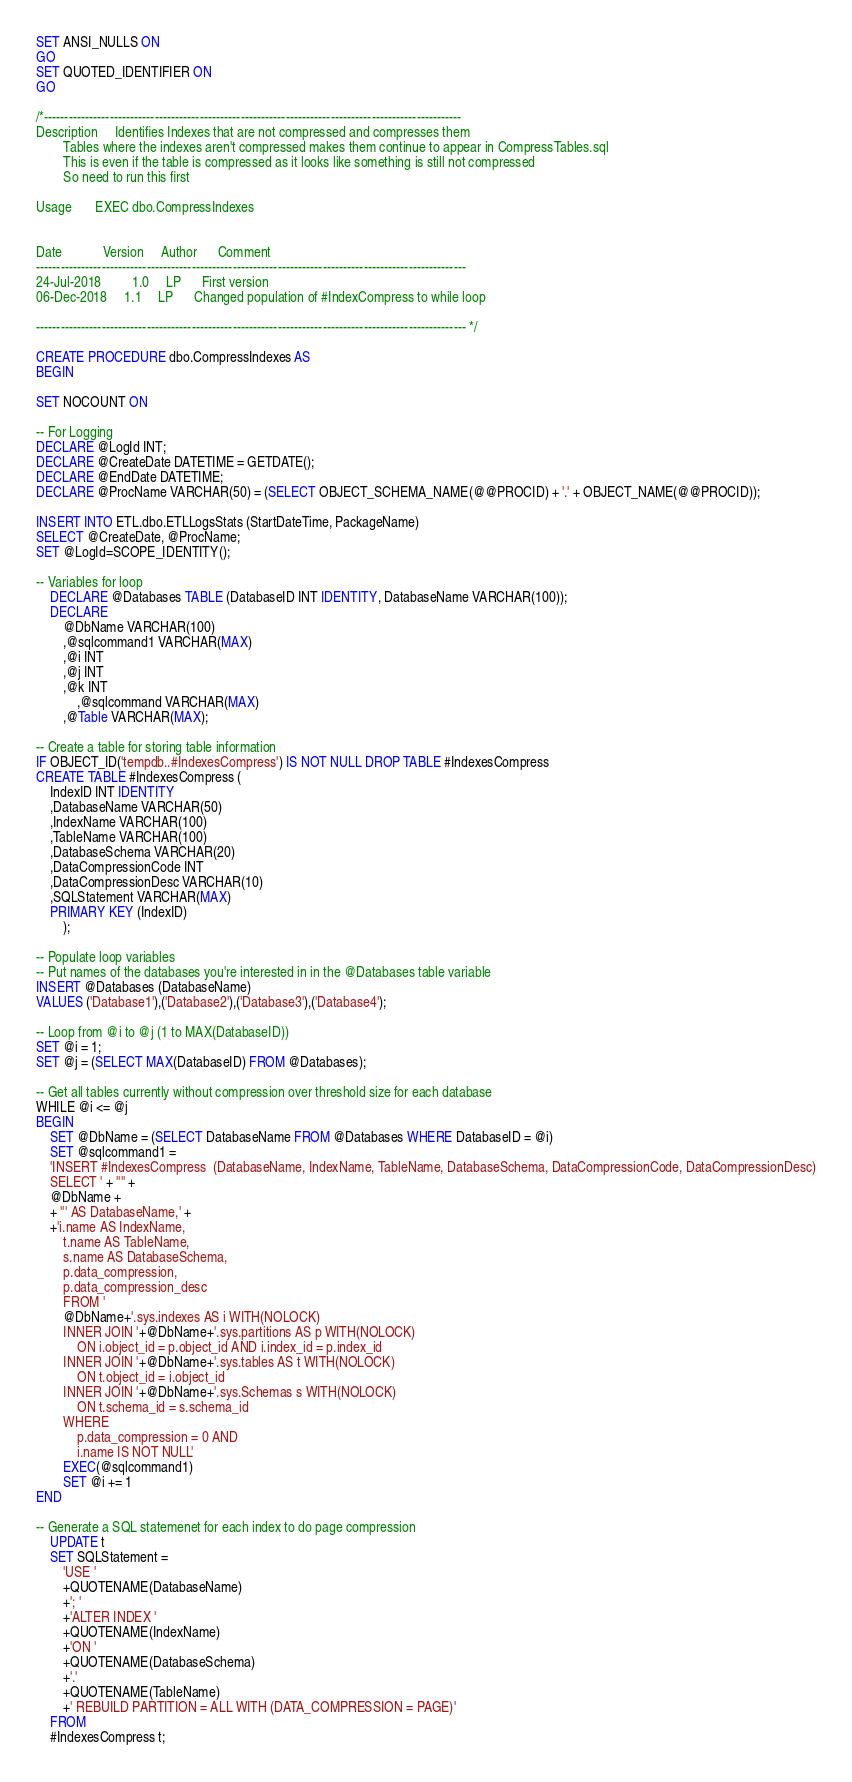Convert code to text. <code><loc_0><loc_0><loc_500><loc_500><_SQL_>SET ANSI_NULLS ON
GO
SET QUOTED_IDENTIFIER ON
GO

/*------------------------------------------------------------------------------------------------------ 
Description   	Identifies Indexes that are not compressed and compresses them
		Tables where the indexes aren't compressed makes them continue to appear in CompressTables.sql
		This is even if the table is compressed as it looks like something is still not compressed
		So need to run this first

Usage		EXEC dbo.CompressIndexes

                 
Date			Version		Author		Comment
---------------------------------------------------------------------------------------------------------
24-Jul-2018	     	1.0		LP		First version
06-Dec-2018		1.1		LP		Changed population of #IndexCompress to while loop

--------------------------------------------------------------------------------------------------------- */

CREATE PROCEDURE dbo.CompressIndexes AS 
BEGIN 

SET NOCOUNT ON

-- For Logging
DECLARE @LogId INT;
DECLARE @CreateDate DATETIME = GETDATE();
DECLARE @EndDate DATETIME;
DECLARE @ProcName VARCHAR(50) = (SELECT OBJECT_SCHEMA_NAME(@@PROCID) + '.' + OBJECT_NAME(@@PROCID));

INSERT INTO ETL.dbo.ETLLogsStats (StartDateTime, PackageName)
SELECT @CreateDate, @ProcName;
SET @LogId=SCOPE_IDENTITY();

-- Variables for loop
	DECLARE @Databases TABLE (DatabaseID INT IDENTITY, DatabaseName VARCHAR(100));
	DECLARE 
		@DbName VARCHAR(100)
		,@sqlcommand1 VARCHAR(MAX)
		,@i INT
		,@j INT
		,@k INT
      		,@sqlcommand VARCHAR(MAX)
		,@Table VARCHAR(MAX);

-- Create a table for storing table information
IF OBJECT_ID('tempdb..#IndexesCompress') IS NOT NULL DROP TABLE #IndexesCompress
CREATE TABLE #IndexesCompress (
	IndexID INT IDENTITY
	,DatabaseName VARCHAR(50)
	,IndexName VARCHAR(100)
	,TableName VARCHAR(100)
	,DatabaseSchema VARCHAR(20)
	,DataCompressionCode INT
	,DataCompressionDesc VARCHAR(10)
	,SQLStatement VARCHAR(MAX)
	PRIMARY KEY (IndexID)
		);

-- Populate loop variables 
-- Put names of the databases you're interested in in the @Databases table variable
INSERT @Databases (DatabaseName) 
VALUES ('Database1'),('Database2'),('Database3'),('Database4');

-- Loop from @i to @j (1 to MAX(DatabaseID))
SET @i = 1;
SET @j = (SELECT MAX(DatabaseID) FROM @Databases);

-- Get all tables currently without compression over threshold size for each database
WHILE @i <= @j
BEGIN
	SET @DbName = (SELECT DatabaseName FROM @Databases WHERE DatabaseID = @i)
	SET @sqlcommand1 =
	'INSERT #IndexesCompress  (DatabaseName, IndexName, TableName, DatabaseSchema, DataCompressionCode, DataCompressionDesc)
	SELECT ' + '''' +
	@DbName +
	+ ''' AS DatabaseName,' +
	+'i.name AS IndexName,
		t.name AS TableName, 
		s.name AS DatabaseSchema,
		p.data_compression, 
		p.data_compression_desc
		FROM '
		@DbName+'.sys.indexes AS i WITH(NOLOCK)
		INNER JOIN '+@DbName+'.sys.partitions AS p WITH(NOLOCK) 
			ON i.object_id = p.object_id AND i.index_id = p.index_id
		INNER JOIN '+@DbName+'.sys.tables AS t WITH(NOLOCK) 
			ON t.object_id = i.object_id
		INNER JOIN '+@DbName+'.sys.Schemas s WITH(NOLOCK) 
			ON t.schema_id = s.schema_id
		WHERE 
			p.data_compression = 0 AND
			i.name IS NOT NULL'
		EXEC(@sqlcommand1)
		SET @i += 1
END

-- Generate a SQL statemenet for each index to do page compression
	UPDATE t
	SET SQLStatement = 
		'USE '
		+QUOTENAME(DatabaseName)
		+'; '
		+'ALTER INDEX '
		+QUOTENAME(IndexName)
		+'ON '
		+QUOTENAME(DatabaseSchema)
		+'.'
		+QUOTENAME(TableName)
		+' REBUILD PARTITION = ALL WITH (DATA_COMPRESSION = PAGE)'
	FROM
	#IndexesCompress t;
</code> 